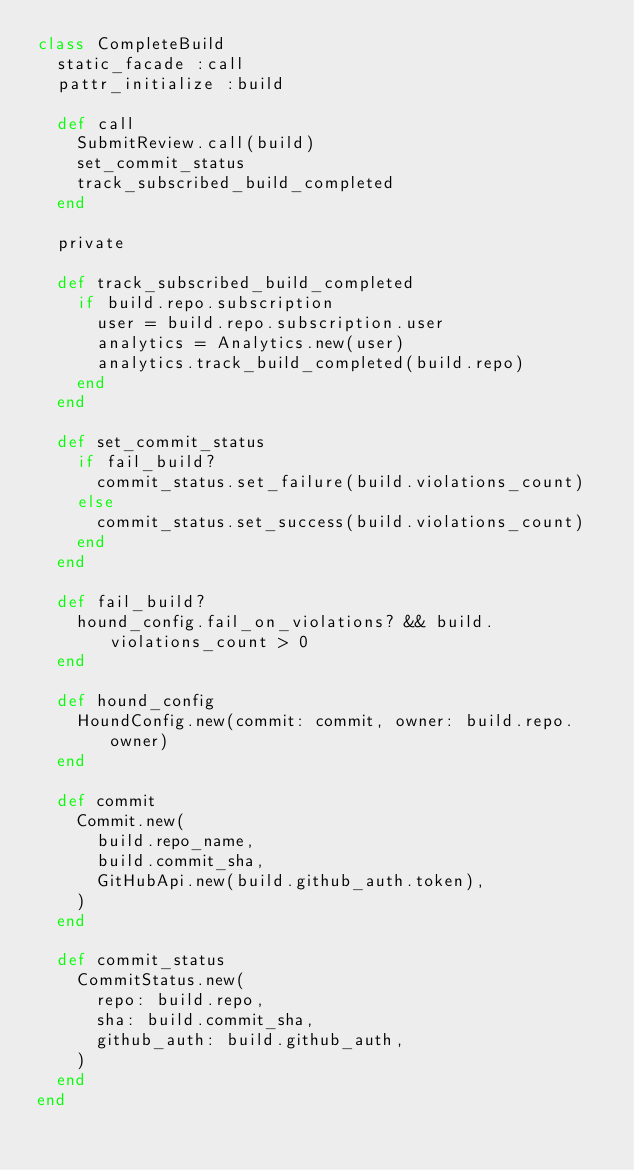<code> <loc_0><loc_0><loc_500><loc_500><_Ruby_>class CompleteBuild
  static_facade :call
  pattr_initialize :build

  def call
    SubmitReview.call(build)
    set_commit_status
    track_subscribed_build_completed
  end

  private

  def track_subscribed_build_completed
    if build.repo.subscription
      user = build.repo.subscription.user
      analytics = Analytics.new(user)
      analytics.track_build_completed(build.repo)
    end
  end

  def set_commit_status
    if fail_build?
      commit_status.set_failure(build.violations_count)
    else
      commit_status.set_success(build.violations_count)
    end
  end

  def fail_build?
    hound_config.fail_on_violations? && build.violations_count > 0
  end

  def hound_config
    HoundConfig.new(commit: commit, owner: build.repo.owner)
  end

  def commit
    Commit.new(
      build.repo_name,
      build.commit_sha,
      GitHubApi.new(build.github_auth.token),
    )
  end

  def commit_status
    CommitStatus.new(
      repo: build.repo,
      sha: build.commit_sha,
      github_auth: build.github_auth,
    )
  end
end
</code> 